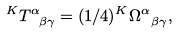Convert formula to latex. <formula><loc_0><loc_0><loc_500><loc_500>\ ^ { K } T _ { \ \beta \gamma } ^ { \alpha } = ( 1 / 4 ) ^ { K } \Omega _ { \ \beta \gamma } ^ { \alpha } ,</formula> 